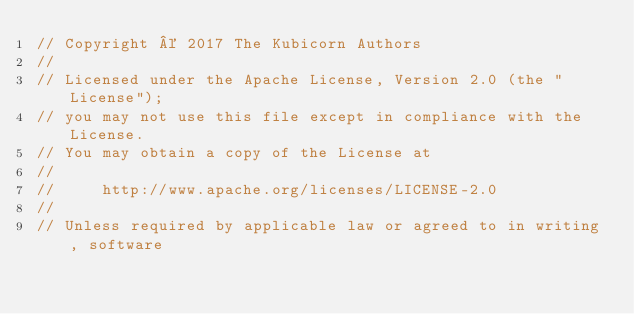Convert code to text. <code><loc_0><loc_0><loc_500><loc_500><_Go_>// Copyright © 2017 The Kubicorn Authors
//
// Licensed under the Apache License, Version 2.0 (the "License");
// you may not use this file except in compliance with the License.
// You may obtain a copy of the License at
//
//     http://www.apache.org/licenses/LICENSE-2.0
//
// Unless required by applicable law or agreed to in writing, software</code> 